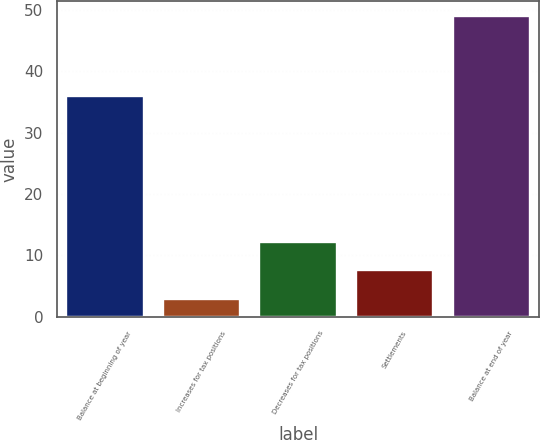Convert chart. <chart><loc_0><loc_0><loc_500><loc_500><bar_chart><fcel>Balance at beginning of year<fcel>Increases for tax positions<fcel>Decreases for tax positions<fcel>Settlements<fcel>Balance at end of year<nl><fcel>36<fcel>3<fcel>12.2<fcel>7.6<fcel>49<nl></chart> 